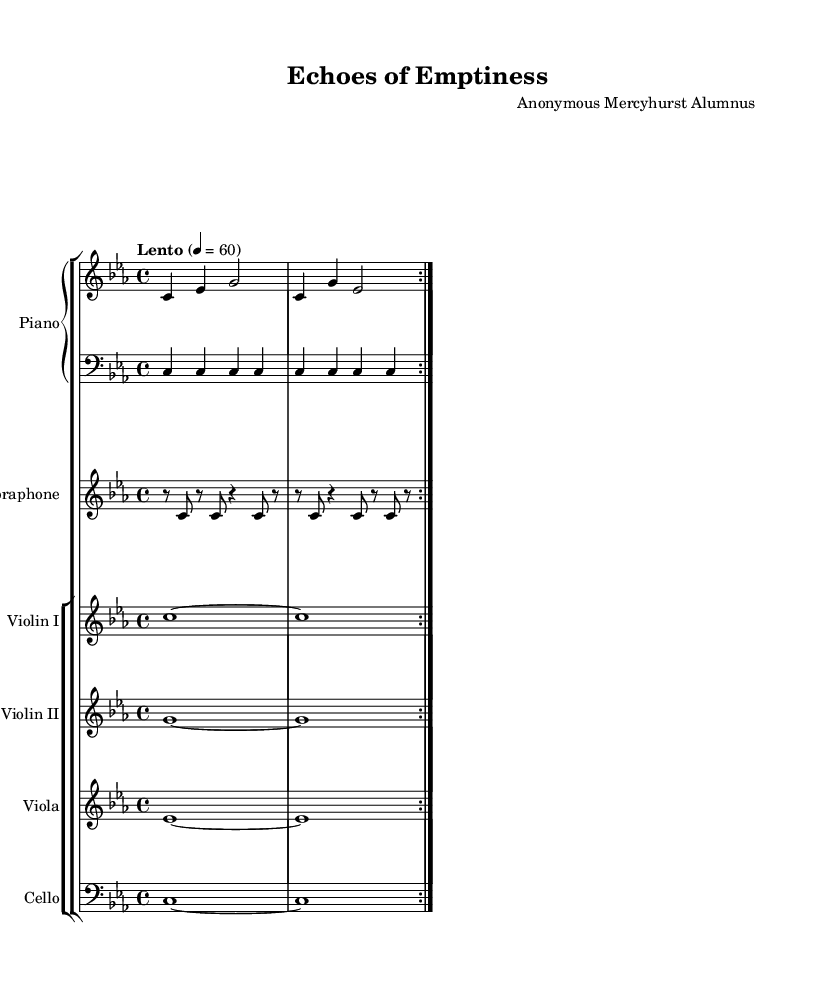What is the key signature of this music? The key signature is C minor, which is indicated by the presence of three flats (B-flat, E-flat, and A-flat).
Answer: C minor What is the time signature of this piece? The time signature is indicated at the beginning of the music as 4/4, meaning there are four beats in each measure and the quarter note receives one beat.
Answer: 4/4 What is the tempo marking for this composition? The tempo marking indicates a "Lento" pace, meaning it is to be played slowly. The specific metronome marking is set at 60 beats per minute.
Answer: Lento How many times is the first section of the piano part repeated? The piano part indicates a repetition of the first section, shown by the "volta" markings that specify repeating the section twice.
Answer: 2 What instruments are featured in this piece? The piece includes a Piano, Vibraphone, Violin I, Violin II, Viola, and Cello, all of which are explicitly notated in their respective staves.
Answer: Piano, Vibraphone, Violin I, Violin II, Viola, Cello Which instrument plays the highest pitch in this composition? The highest pitch is played by the Violin I, which is indicated to play in a higher octave compared to the other string instruments.
Answer: Violin I 